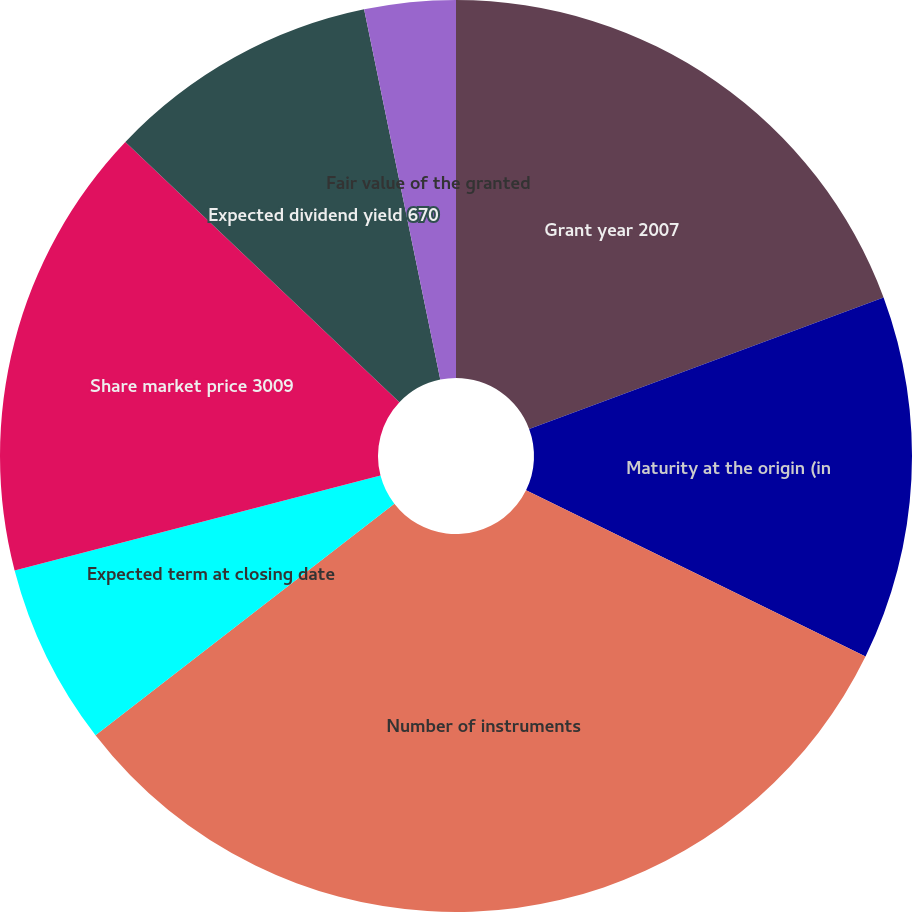Convert chart to OTSL. <chart><loc_0><loc_0><loc_500><loc_500><pie_chart><fcel>Grant year 2007<fcel>Maturity at the origin (in<fcel>Number of instruments<fcel>Expected term at closing date<fcel>Share market price 3009<fcel>Expected dividend yield 670<fcel>Fair value of the granted<fcel>Fair value of the plan as of<nl><fcel>19.35%<fcel>12.9%<fcel>32.26%<fcel>6.45%<fcel>16.13%<fcel>9.68%<fcel>3.23%<fcel>0.0%<nl></chart> 